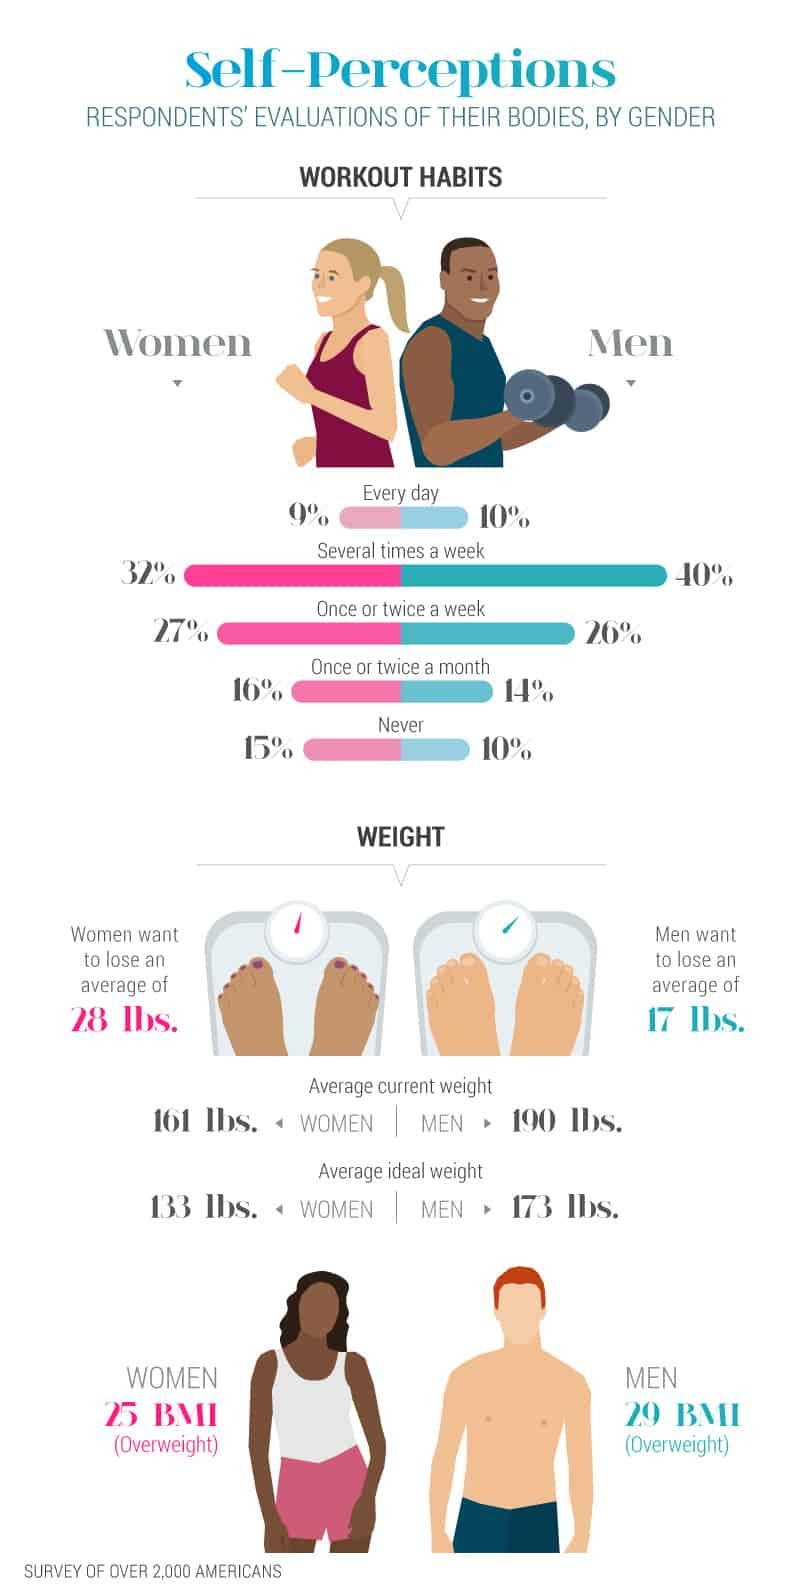List a handful of essential elements in this visual. A recent study found that, when compared to women, men are more likely to work out several times a week, with an 8% difference in frequency. The body mass index of women who are above the normal weight, which ranges from 29 to 25, is a topic of interest. The ratio of women who do not work out is 3 to 20. According to a recent survey, only 10% of men have a daily routine for working out. This is a relatively low percentage, with some individuals falling within the range of 9% and 40%. It is important to maintain a consistent exercise routine in order to see results and improve overall health. The average weight men want to reduce is 17 pounds. 